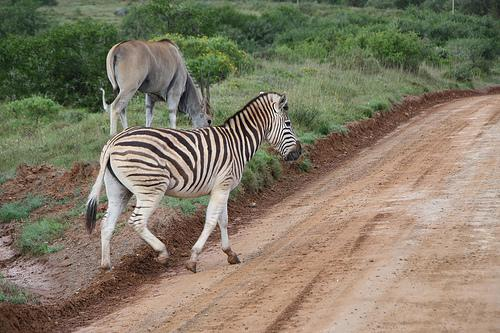Question: how many animals are in the picture?
Choices:
A. Three.
B. Five.
C. Nine.
D. Two.
Answer with the letter. Answer: D Question: what species of animal is closest to the road?
Choices:
A. Grizzly Bear.
B. Dog.
C. Zebra.
D. Cat.
Answer with the letter. Answer: C Question: what species is eating grass in the photo?
Choices:
A. Giraffe.
B. Elephant.
C. Lion.
D. The antelope.
Answer with the letter. Answer: D Question: when is this photo taken?
Choices:
A. Night.
B. Daylight.
C. Morning.
D. Noon.
Answer with the letter. Answer: B Question: where is this photo taken?
Choices:
A. North Carolina.
B. Africa.
C. South Carolina.
D. New York.
Answer with the letter. Answer: B 